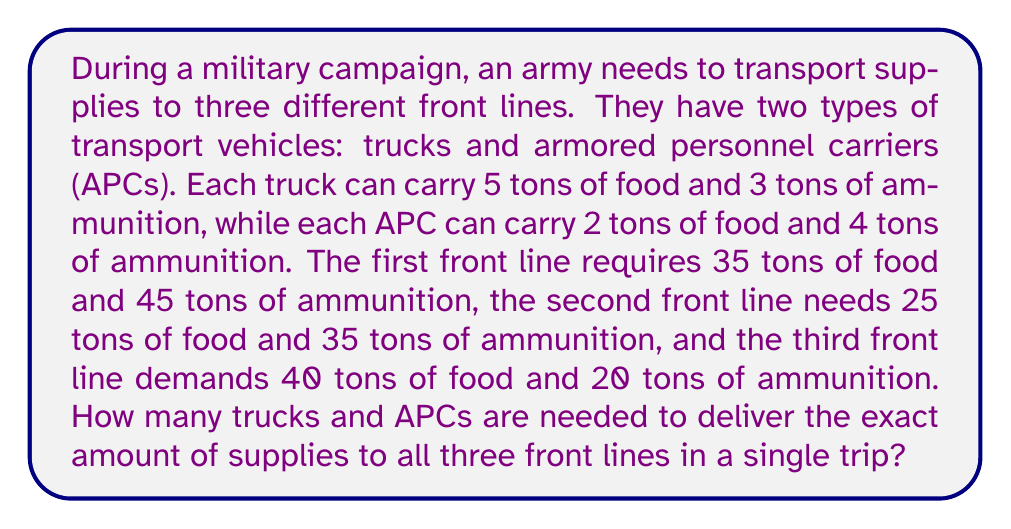Can you answer this question? Let's approach this problem using a system of linear equations. We'll define our variables as:
$x$ = number of trucks
$y$ = number of APCs

Now, let's set up our equations based on the given information:

1. For food supplies:
   $5x + 2y = 100$ (35 + 25 + 40 = 100 tons of food)

2. For ammunition supplies:
   $3x + 4y = 100$ (45 + 35 + 20 = 100 tons of ammunition)

We now have a system of two equations with two unknowns:

$$\begin{cases}
5x + 2y = 100 \\
3x + 4y = 100
\end{cases}$$

To solve this system, we can use the elimination method:

1. Multiply the first equation by 3 and the second equation by -5:
   $$\begin{cases}
   15x + 6y = 300 \\
   -15x - 20y = -500
   \end{cases}$$

2. Add the equations:
   $-14y = -200$

3. Solve for $y$:
   $y = \frac{200}{14} = \frac{100}{7} \approx 14.29$

Since we can't have a fractional number of vehicles, we need to round up to the nearest whole number:
$y = 15$ APCs

4. Substitute this value back into either of the original equations to solve for $x$:
   $5x + 2(15) = 100$
   $5x + 30 = 100$
   $5x = 70$
   $x = 14$ trucks

5. Verify the solution:
   For food: $5(14) + 2(15) = 70 + 30 = 100$
   For ammunition: $3(14) + 4(15) = 42 + 60 = 102$

The slight excess in ammunition (2 tons) is due to rounding up the number of APCs, which is necessary to meet the minimum requirements for all front lines.
Answer: 14 trucks and 15 APCs are needed to deliver the required supplies to all three front lines in a single trip. 